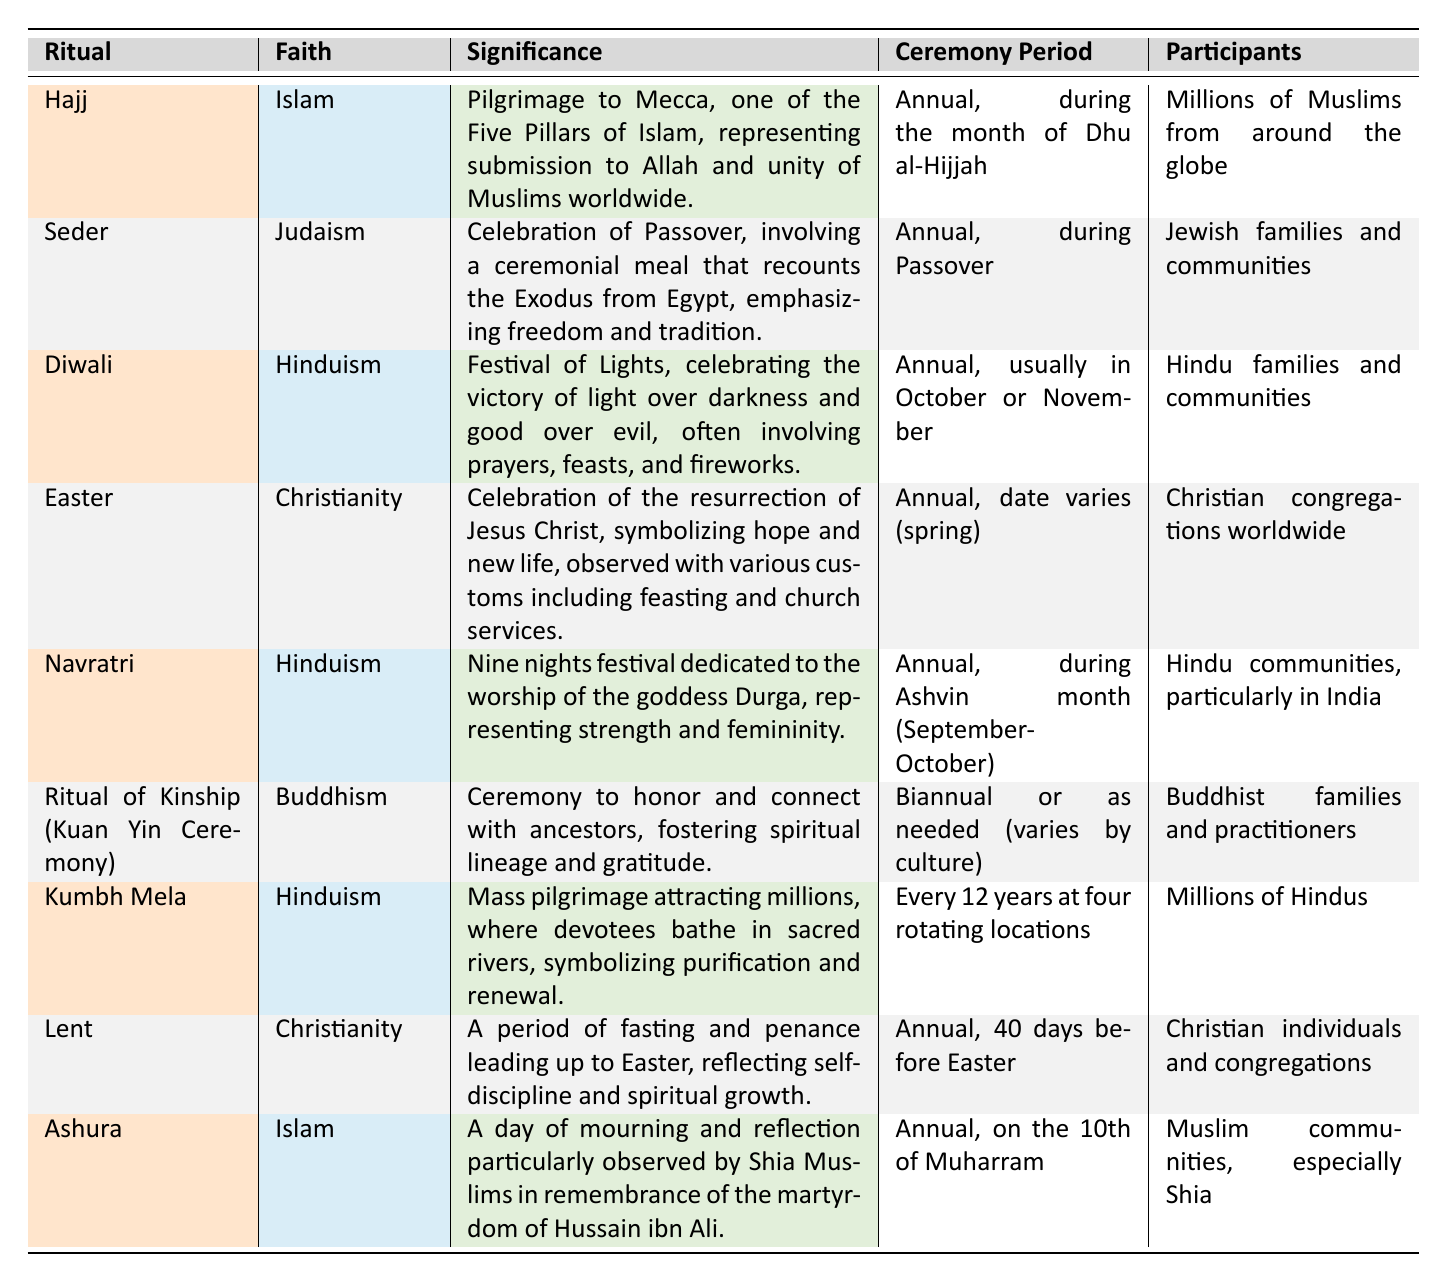What is the significance of Diwali? Diwali is described as the Festival of Lights, which celebrates the victory of light over darkness and good over evil. It typically involves prayers, feasts, and fireworks.
Answer: Festival of Lights, celebrating the victory of light over darkness and good over evil In which month does the Hajj ceremony take place? The Hajj ceremony is observed annually during the month of Dhu al-Hijjah, as stated in the table.
Answer: Dhu al-Hijjah Which faith has a ritual involving fasting and penance for 40 days? The ritual that involves fasting and penance for 40 days leading up to Easter is Lent, which belongs to Christianity.
Answer: Christianity Is Kumbh Mela celebrated every year? No, Kumbh Mela is celebrated every 12 years at four rotating locations, indicating it is not an annual event.
Answer: No During which month is Navratri celebrated? Navratri is celebrated during the Ashvin month, which generally falls in September and October. This is outlined in the table under the ceremony period.
Answer: September-October How many participants are involved in the Kumbh Mela? The Kumbh Mela attracts millions of Hindus, as stated in the participants section of the table.
Answer: Millions of Hindus Is the Seder ceremony linked to Judaism? Yes, the Seder ceremony is specifically noted as a celebration of Passover within the Judaism faith.
Answer: Yes What is a common feature of major Hindu rituals like Diwali and Kumbh Mela? Both Diwali and Kumbh Mela emphasize themes of celebration and purification, as Diwali celebrates light over darkness and Kumbh Mela involves bathing in sacred rivers for renewal.
Answer: Celebration and Purification What is the relationship between Ashura and Hussain ibn Ali? Ashura is a day of mourning and reflection particularly observed by Shia Muslims in remembrance of Hussain ibn Ali's martyrdom, linking the two directly.
Answer: Mourning for Hussain ibn Ali 